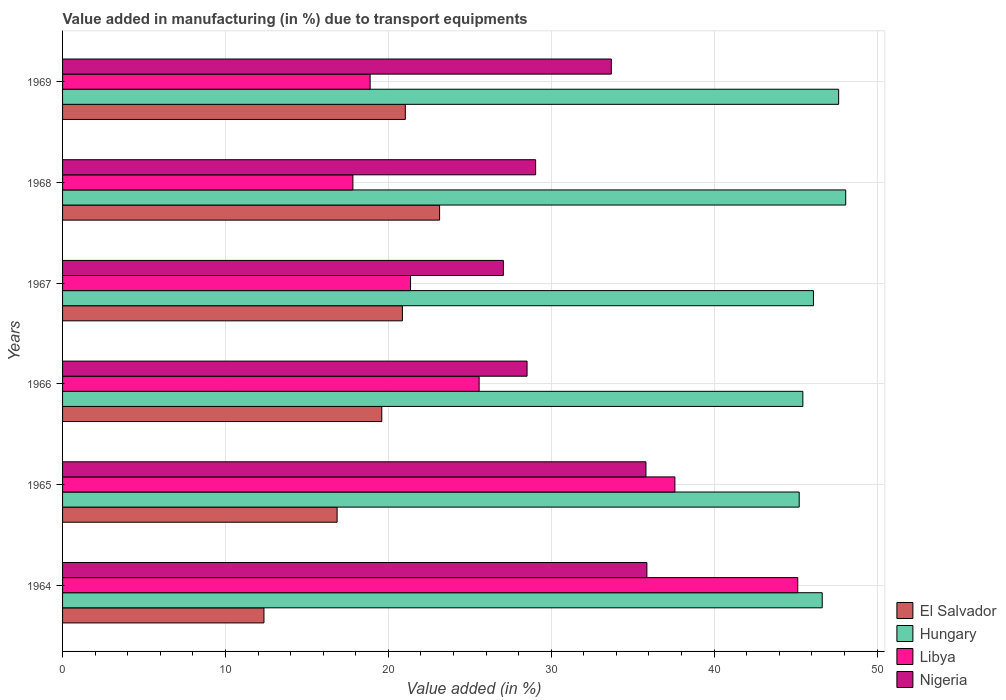How many different coloured bars are there?
Your response must be concise. 4. Are the number of bars per tick equal to the number of legend labels?
Offer a terse response. Yes. Are the number of bars on each tick of the Y-axis equal?
Offer a terse response. Yes. How many bars are there on the 5th tick from the top?
Make the answer very short. 4. What is the label of the 4th group of bars from the top?
Provide a succinct answer. 1966. What is the percentage of value added in manufacturing due to transport equipments in Nigeria in 1966?
Give a very brief answer. 28.52. Across all years, what is the maximum percentage of value added in manufacturing due to transport equipments in Nigeria?
Give a very brief answer. 35.87. Across all years, what is the minimum percentage of value added in manufacturing due to transport equipments in Libya?
Provide a short and direct response. 17.82. In which year was the percentage of value added in manufacturing due to transport equipments in El Salvador maximum?
Your response must be concise. 1968. In which year was the percentage of value added in manufacturing due to transport equipments in Hungary minimum?
Keep it short and to the point. 1965. What is the total percentage of value added in manufacturing due to transport equipments in Libya in the graph?
Offer a terse response. 166.37. What is the difference between the percentage of value added in manufacturing due to transport equipments in El Salvador in 1964 and that in 1969?
Keep it short and to the point. -8.68. What is the difference between the percentage of value added in manufacturing due to transport equipments in Libya in 1964 and the percentage of value added in manufacturing due to transport equipments in Nigeria in 1966?
Your answer should be very brief. 16.62. What is the average percentage of value added in manufacturing due to transport equipments in Libya per year?
Provide a succinct answer. 27.73. In the year 1966, what is the difference between the percentage of value added in manufacturing due to transport equipments in Hungary and percentage of value added in manufacturing due to transport equipments in Libya?
Provide a short and direct response. 19.87. What is the ratio of the percentage of value added in manufacturing due to transport equipments in Libya in 1968 to that in 1969?
Ensure brevity in your answer.  0.94. What is the difference between the highest and the second highest percentage of value added in manufacturing due to transport equipments in Hungary?
Provide a short and direct response. 0.43. What is the difference between the highest and the lowest percentage of value added in manufacturing due to transport equipments in Hungary?
Offer a terse response. 2.86. Is it the case that in every year, the sum of the percentage of value added in manufacturing due to transport equipments in El Salvador and percentage of value added in manufacturing due to transport equipments in Nigeria is greater than the sum of percentage of value added in manufacturing due to transport equipments in Libya and percentage of value added in manufacturing due to transport equipments in Hungary?
Make the answer very short. No. What does the 1st bar from the top in 1966 represents?
Your answer should be very brief. Nigeria. What does the 2nd bar from the bottom in 1964 represents?
Your answer should be very brief. Hungary. How many bars are there?
Offer a terse response. 24. What is the difference between two consecutive major ticks on the X-axis?
Provide a short and direct response. 10. Does the graph contain any zero values?
Provide a succinct answer. No. Does the graph contain grids?
Ensure brevity in your answer.  Yes. How are the legend labels stacked?
Offer a terse response. Vertical. What is the title of the graph?
Make the answer very short. Value added in manufacturing (in %) due to transport equipments. What is the label or title of the X-axis?
Offer a very short reply. Value added (in %). What is the Value added (in %) of El Salvador in 1964?
Ensure brevity in your answer.  12.36. What is the Value added (in %) in Hungary in 1964?
Ensure brevity in your answer.  46.64. What is the Value added (in %) of Libya in 1964?
Make the answer very short. 45.13. What is the Value added (in %) of Nigeria in 1964?
Your answer should be compact. 35.87. What is the Value added (in %) of El Salvador in 1965?
Offer a very short reply. 16.85. What is the Value added (in %) of Hungary in 1965?
Ensure brevity in your answer.  45.22. What is the Value added (in %) in Libya in 1965?
Give a very brief answer. 37.59. What is the Value added (in %) in Nigeria in 1965?
Give a very brief answer. 35.82. What is the Value added (in %) of El Salvador in 1966?
Give a very brief answer. 19.6. What is the Value added (in %) of Hungary in 1966?
Ensure brevity in your answer.  45.45. What is the Value added (in %) of Libya in 1966?
Give a very brief answer. 25.57. What is the Value added (in %) of Nigeria in 1966?
Offer a terse response. 28.52. What is the Value added (in %) in El Salvador in 1967?
Keep it short and to the point. 20.86. What is the Value added (in %) of Hungary in 1967?
Ensure brevity in your answer.  46.1. What is the Value added (in %) of Libya in 1967?
Give a very brief answer. 21.36. What is the Value added (in %) in Nigeria in 1967?
Provide a succinct answer. 27.06. What is the Value added (in %) in El Salvador in 1968?
Your answer should be compact. 23.15. What is the Value added (in %) in Hungary in 1968?
Make the answer very short. 48.08. What is the Value added (in %) of Libya in 1968?
Your answer should be very brief. 17.82. What is the Value added (in %) of Nigeria in 1968?
Offer a terse response. 29.04. What is the Value added (in %) of El Salvador in 1969?
Keep it short and to the point. 21.04. What is the Value added (in %) in Hungary in 1969?
Make the answer very short. 47.65. What is the Value added (in %) in Libya in 1969?
Offer a terse response. 18.88. What is the Value added (in %) of Nigeria in 1969?
Offer a terse response. 33.69. Across all years, what is the maximum Value added (in %) of El Salvador?
Provide a succinct answer. 23.15. Across all years, what is the maximum Value added (in %) in Hungary?
Your answer should be compact. 48.08. Across all years, what is the maximum Value added (in %) of Libya?
Offer a very short reply. 45.13. Across all years, what is the maximum Value added (in %) in Nigeria?
Provide a short and direct response. 35.87. Across all years, what is the minimum Value added (in %) of El Salvador?
Provide a short and direct response. 12.36. Across all years, what is the minimum Value added (in %) of Hungary?
Provide a short and direct response. 45.22. Across all years, what is the minimum Value added (in %) of Libya?
Offer a very short reply. 17.82. Across all years, what is the minimum Value added (in %) in Nigeria?
Ensure brevity in your answer.  27.06. What is the total Value added (in %) of El Salvador in the graph?
Make the answer very short. 113.87. What is the total Value added (in %) of Hungary in the graph?
Offer a very short reply. 279.13. What is the total Value added (in %) in Libya in the graph?
Your answer should be compact. 166.37. What is the total Value added (in %) in Nigeria in the graph?
Your answer should be very brief. 190. What is the difference between the Value added (in %) in El Salvador in 1964 and that in 1965?
Provide a short and direct response. -4.49. What is the difference between the Value added (in %) of Hungary in 1964 and that in 1965?
Your answer should be very brief. 1.41. What is the difference between the Value added (in %) of Libya in 1964 and that in 1965?
Offer a very short reply. 7.54. What is the difference between the Value added (in %) of Nigeria in 1964 and that in 1965?
Make the answer very short. 0.06. What is the difference between the Value added (in %) in El Salvador in 1964 and that in 1966?
Keep it short and to the point. -7.23. What is the difference between the Value added (in %) in Hungary in 1964 and that in 1966?
Provide a succinct answer. 1.19. What is the difference between the Value added (in %) of Libya in 1964 and that in 1966?
Your response must be concise. 19.56. What is the difference between the Value added (in %) of Nigeria in 1964 and that in 1966?
Ensure brevity in your answer.  7.36. What is the difference between the Value added (in %) in El Salvador in 1964 and that in 1967?
Offer a terse response. -8.5. What is the difference between the Value added (in %) in Hungary in 1964 and that in 1967?
Your answer should be compact. 0.54. What is the difference between the Value added (in %) in Libya in 1964 and that in 1967?
Offer a terse response. 23.77. What is the difference between the Value added (in %) of Nigeria in 1964 and that in 1967?
Provide a short and direct response. 8.81. What is the difference between the Value added (in %) in El Salvador in 1964 and that in 1968?
Ensure brevity in your answer.  -10.78. What is the difference between the Value added (in %) of Hungary in 1964 and that in 1968?
Offer a terse response. -1.44. What is the difference between the Value added (in %) in Libya in 1964 and that in 1968?
Provide a succinct answer. 27.31. What is the difference between the Value added (in %) of Nigeria in 1964 and that in 1968?
Make the answer very short. 6.83. What is the difference between the Value added (in %) of El Salvador in 1964 and that in 1969?
Your response must be concise. -8.68. What is the difference between the Value added (in %) of Hungary in 1964 and that in 1969?
Offer a very short reply. -1.01. What is the difference between the Value added (in %) in Libya in 1964 and that in 1969?
Your response must be concise. 26.25. What is the difference between the Value added (in %) of Nigeria in 1964 and that in 1969?
Your answer should be compact. 2.18. What is the difference between the Value added (in %) in El Salvador in 1965 and that in 1966?
Your response must be concise. -2.74. What is the difference between the Value added (in %) of Hungary in 1965 and that in 1966?
Give a very brief answer. -0.22. What is the difference between the Value added (in %) in Libya in 1965 and that in 1966?
Make the answer very short. 12.02. What is the difference between the Value added (in %) of Nigeria in 1965 and that in 1966?
Keep it short and to the point. 7.3. What is the difference between the Value added (in %) of El Salvador in 1965 and that in 1967?
Provide a short and direct response. -4.01. What is the difference between the Value added (in %) in Hungary in 1965 and that in 1967?
Ensure brevity in your answer.  -0.88. What is the difference between the Value added (in %) of Libya in 1965 and that in 1967?
Provide a succinct answer. 16.23. What is the difference between the Value added (in %) of Nigeria in 1965 and that in 1967?
Keep it short and to the point. 8.75. What is the difference between the Value added (in %) of El Salvador in 1965 and that in 1968?
Offer a terse response. -6.29. What is the difference between the Value added (in %) of Hungary in 1965 and that in 1968?
Keep it short and to the point. -2.86. What is the difference between the Value added (in %) of Libya in 1965 and that in 1968?
Your answer should be compact. 19.77. What is the difference between the Value added (in %) of Nigeria in 1965 and that in 1968?
Ensure brevity in your answer.  6.77. What is the difference between the Value added (in %) of El Salvador in 1965 and that in 1969?
Provide a succinct answer. -4.19. What is the difference between the Value added (in %) of Hungary in 1965 and that in 1969?
Provide a succinct answer. -2.42. What is the difference between the Value added (in %) of Libya in 1965 and that in 1969?
Offer a terse response. 18.71. What is the difference between the Value added (in %) in Nigeria in 1965 and that in 1969?
Ensure brevity in your answer.  2.13. What is the difference between the Value added (in %) in El Salvador in 1966 and that in 1967?
Provide a succinct answer. -1.27. What is the difference between the Value added (in %) of Hungary in 1966 and that in 1967?
Your answer should be very brief. -0.65. What is the difference between the Value added (in %) of Libya in 1966 and that in 1967?
Keep it short and to the point. 4.21. What is the difference between the Value added (in %) in Nigeria in 1966 and that in 1967?
Ensure brevity in your answer.  1.45. What is the difference between the Value added (in %) of El Salvador in 1966 and that in 1968?
Your response must be concise. -3.55. What is the difference between the Value added (in %) of Hungary in 1966 and that in 1968?
Offer a very short reply. -2.63. What is the difference between the Value added (in %) in Libya in 1966 and that in 1968?
Provide a short and direct response. 7.75. What is the difference between the Value added (in %) in Nigeria in 1966 and that in 1968?
Give a very brief answer. -0.53. What is the difference between the Value added (in %) in El Salvador in 1966 and that in 1969?
Offer a terse response. -1.44. What is the difference between the Value added (in %) of Hungary in 1966 and that in 1969?
Make the answer very short. -2.2. What is the difference between the Value added (in %) of Libya in 1966 and that in 1969?
Make the answer very short. 6.69. What is the difference between the Value added (in %) of Nigeria in 1966 and that in 1969?
Offer a terse response. -5.17. What is the difference between the Value added (in %) of El Salvador in 1967 and that in 1968?
Provide a short and direct response. -2.28. What is the difference between the Value added (in %) of Hungary in 1967 and that in 1968?
Offer a terse response. -1.98. What is the difference between the Value added (in %) in Libya in 1967 and that in 1968?
Your answer should be very brief. 3.54. What is the difference between the Value added (in %) of Nigeria in 1967 and that in 1968?
Your response must be concise. -1.98. What is the difference between the Value added (in %) of El Salvador in 1967 and that in 1969?
Ensure brevity in your answer.  -0.18. What is the difference between the Value added (in %) of Hungary in 1967 and that in 1969?
Give a very brief answer. -1.55. What is the difference between the Value added (in %) in Libya in 1967 and that in 1969?
Provide a short and direct response. 2.48. What is the difference between the Value added (in %) in Nigeria in 1967 and that in 1969?
Your response must be concise. -6.63. What is the difference between the Value added (in %) in El Salvador in 1968 and that in 1969?
Give a very brief answer. 2.1. What is the difference between the Value added (in %) in Hungary in 1968 and that in 1969?
Make the answer very short. 0.43. What is the difference between the Value added (in %) in Libya in 1968 and that in 1969?
Offer a very short reply. -1.06. What is the difference between the Value added (in %) in Nigeria in 1968 and that in 1969?
Provide a short and direct response. -4.65. What is the difference between the Value added (in %) of El Salvador in 1964 and the Value added (in %) of Hungary in 1965?
Give a very brief answer. -32.86. What is the difference between the Value added (in %) in El Salvador in 1964 and the Value added (in %) in Libya in 1965?
Offer a very short reply. -25.23. What is the difference between the Value added (in %) in El Salvador in 1964 and the Value added (in %) in Nigeria in 1965?
Ensure brevity in your answer.  -23.45. What is the difference between the Value added (in %) in Hungary in 1964 and the Value added (in %) in Libya in 1965?
Provide a succinct answer. 9.04. What is the difference between the Value added (in %) in Hungary in 1964 and the Value added (in %) in Nigeria in 1965?
Your answer should be very brief. 10.82. What is the difference between the Value added (in %) in Libya in 1964 and the Value added (in %) in Nigeria in 1965?
Keep it short and to the point. 9.32. What is the difference between the Value added (in %) in El Salvador in 1964 and the Value added (in %) in Hungary in 1966?
Offer a very short reply. -33.08. What is the difference between the Value added (in %) of El Salvador in 1964 and the Value added (in %) of Libya in 1966?
Your response must be concise. -13.21. What is the difference between the Value added (in %) of El Salvador in 1964 and the Value added (in %) of Nigeria in 1966?
Your response must be concise. -16.15. What is the difference between the Value added (in %) in Hungary in 1964 and the Value added (in %) in Libya in 1966?
Provide a succinct answer. 21.06. What is the difference between the Value added (in %) of Hungary in 1964 and the Value added (in %) of Nigeria in 1966?
Give a very brief answer. 18.12. What is the difference between the Value added (in %) of Libya in 1964 and the Value added (in %) of Nigeria in 1966?
Your answer should be very brief. 16.62. What is the difference between the Value added (in %) of El Salvador in 1964 and the Value added (in %) of Hungary in 1967?
Ensure brevity in your answer.  -33.73. What is the difference between the Value added (in %) of El Salvador in 1964 and the Value added (in %) of Libya in 1967?
Your answer should be compact. -9. What is the difference between the Value added (in %) in El Salvador in 1964 and the Value added (in %) in Nigeria in 1967?
Your response must be concise. -14.7. What is the difference between the Value added (in %) in Hungary in 1964 and the Value added (in %) in Libya in 1967?
Make the answer very short. 25.27. What is the difference between the Value added (in %) in Hungary in 1964 and the Value added (in %) in Nigeria in 1967?
Ensure brevity in your answer.  19.57. What is the difference between the Value added (in %) of Libya in 1964 and the Value added (in %) of Nigeria in 1967?
Provide a short and direct response. 18.07. What is the difference between the Value added (in %) of El Salvador in 1964 and the Value added (in %) of Hungary in 1968?
Offer a very short reply. -35.72. What is the difference between the Value added (in %) in El Salvador in 1964 and the Value added (in %) in Libya in 1968?
Your answer should be compact. -5.46. What is the difference between the Value added (in %) in El Salvador in 1964 and the Value added (in %) in Nigeria in 1968?
Keep it short and to the point. -16.68. What is the difference between the Value added (in %) of Hungary in 1964 and the Value added (in %) of Libya in 1968?
Your answer should be very brief. 28.81. What is the difference between the Value added (in %) in Hungary in 1964 and the Value added (in %) in Nigeria in 1968?
Your response must be concise. 17.59. What is the difference between the Value added (in %) of Libya in 1964 and the Value added (in %) of Nigeria in 1968?
Your answer should be compact. 16.09. What is the difference between the Value added (in %) in El Salvador in 1964 and the Value added (in %) in Hungary in 1969?
Your response must be concise. -35.28. What is the difference between the Value added (in %) in El Salvador in 1964 and the Value added (in %) in Libya in 1969?
Your response must be concise. -6.52. What is the difference between the Value added (in %) in El Salvador in 1964 and the Value added (in %) in Nigeria in 1969?
Offer a terse response. -21.33. What is the difference between the Value added (in %) of Hungary in 1964 and the Value added (in %) of Libya in 1969?
Give a very brief answer. 27.75. What is the difference between the Value added (in %) of Hungary in 1964 and the Value added (in %) of Nigeria in 1969?
Ensure brevity in your answer.  12.95. What is the difference between the Value added (in %) in Libya in 1964 and the Value added (in %) in Nigeria in 1969?
Your answer should be very brief. 11.44. What is the difference between the Value added (in %) of El Salvador in 1965 and the Value added (in %) of Hungary in 1966?
Provide a succinct answer. -28.59. What is the difference between the Value added (in %) in El Salvador in 1965 and the Value added (in %) in Libya in 1966?
Give a very brief answer. -8.72. What is the difference between the Value added (in %) in El Salvador in 1965 and the Value added (in %) in Nigeria in 1966?
Make the answer very short. -11.66. What is the difference between the Value added (in %) of Hungary in 1965 and the Value added (in %) of Libya in 1966?
Offer a terse response. 19.65. What is the difference between the Value added (in %) in Hungary in 1965 and the Value added (in %) in Nigeria in 1966?
Offer a terse response. 16.71. What is the difference between the Value added (in %) of Libya in 1965 and the Value added (in %) of Nigeria in 1966?
Your response must be concise. 9.08. What is the difference between the Value added (in %) of El Salvador in 1965 and the Value added (in %) of Hungary in 1967?
Offer a terse response. -29.24. What is the difference between the Value added (in %) in El Salvador in 1965 and the Value added (in %) in Libya in 1967?
Make the answer very short. -4.51. What is the difference between the Value added (in %) of El Salvador in 1965 and the Value added (in %) of Nigeria in 1967?
Keep it short and to the point. -10.21. What is the difference between the Value added (in %) of Hungary in 1965 and the Value added (in %) of Libya in 1967?
Give a very brief answer. 23.86. What is the difference between the Value added (in %) of Hungary in 1965 and the Value added (in %) of Nigeria in 1967?
Your response must be concise. 18.16. What is the difference between the Value added (in %) in Libya in 1965 and the Value added (in %) in Nigeria in 1967?
Offer a very short reply. 10.53. What is the difference between the Value added (in %) of El Salvador in 1965 and the Value added (in %) of Hungary in 1968?
Your response must be concise. -31.22. What is the difference between the Value added (in %) in El Salvador in 1965 and the Value added (in %) in Libya in 1968?
Your answer should be very brief. -0.97. What is the difference between the Value added (in %) of El Salvador in 1965 and the Value added (in %) of Nigeria in 1968?
Make the answer very short. -12.19. What is the difference between the Value added (in %) of Hungary in 1965 and the Value added (in %) of Libya in 1968?
Make the answer very short. 27.4. What is the difference between the Value added (in %) of Hungary in 1965 and the Value added (in %) of Nigeria in 1968?
Give a very brief answer. 16.18. What is the difference between the Value added (in %) in Libya in 1965 and the Value added (in %) in Nigeria in 1968?
Your answer should be very brief. 8.55. What is the difference between the Value added (in %) in El Salvador in 1965 and the Value added (in %) in Hungary in 1969?
Your response must be concise. -30.79. What is the difference between the Value added (in %) in El Salvador in 1965 and the Value added (in %) in Libya in 1969?
Your answer should be very brief. -2.03. What is the difference between the Value added (in %) in El Salvador in 1965 and the Value added (in %) in Nigeria in 1969?
Offer a terse response. -16.84. What is the difference between the Value added (in %) of Hungary in 1965 and the Value added (in %) of Libya in 1969?
Make the answer very short. 26.34. What is the difference between the Value added (in %) of Hungary in 1965 and the Value added (in %) of Nigeria in 1969?
Keep it short and to the point. 11.53. What is the difference between the Value added (in %) of Libya in 1965 and the Value added (in %) of Nigeria in 1969?
Give a very brief answer. 3.9. What is the difference between the Value added (in %) in El Salvador in 1966 and the Value added (in %) in Hungary in 1967?
Your answer should be compact. -26.5. What is the difference between the Value added (in %) of El Salvador in 1966 and the Value added (in %) of Libya in 1967?
Provide a succinct answer. -1.77. What is the difference between the Value added (in %) of El Salvador in 1966 and the Value added (in %) of Nigeria in 1967?
Your response must be concise. -7.46. What is the difference between the Value added (in %) in Hungary in 1966 and the Value added (in %) in Libya in 1967?
Provide a short and direct response. 24.08. What is the difference between the Value added (in %) in Hungary in 1966 and the Value added (in %) in Nigeria in 1967?
Offer a terse response. 18.38. What is the difference between the Value added (in %) in Libya in 1966 and the Value added (in %) in Nigeria in 1967?
Keep it short and to the point. -1.49. What is the difference between the Value added (in %) of El Salvador in 1966 and the Value added (in %) of Hungary in 1968?
Offer a very short reply. -28.48. What is the difference between the Value added (in %) in El Salvador in 1966 and the Value added (in %) in Libya in 1968?
Give a very brief answer. 1.77. What is the difference between the Value added (in %) in El Salvador in 1966 and the Value added (in %) in Nigeria in 1968?
Your answer should be compact. -9.45. What is the difference between the Value added (in %) in Hungary in 1966 and the Value added (in %) in Libya in 1968?
Your answer should be very brief. 27.62. What is the difference between the Value added (in %) in Hungary in 1966 and the Value added (in %) in Nigeria in 1968?
Keep it short and to the point. 16.4. What is the difference between the Value added (in %) of Libya in 1966 and the Value added (in %) of Nigeria in 1968?
Offer a terse response. -3.47. What is the difference between the Value added (in %) of El Salvador in 1966 and the Value added (in %) of Hungary in 1969?
Keep it short and to the point. -28.05. What is the difference between the Value added (in %) of El Salvador in 1966 and the Value added (in %) of Libya in 1969?
Provide a succinct answer. 0.72. What is the difference between the Value added (in %) in El Salvador in 1966 and the Value added (in %) in Nigeria in 1969?
Provide a short and direct response. -14.09. What is the difference between the Value added (in %) in Hungary in 1966 and the Value added (in %) in Libya in 1969?
Provide a short and direct response. 26.56. What is the difference between the Value added (in %) in Hungary in 1966 and the Value added (in %) in Nigeria in 1969?
Keep it short and to the point. 11.76. What is the difference between the Value added (in %) in Libya in 1966 and the Value added (in %) in Nigeria in 1969?
Keep it short and to the point. -8.12. What is the difference between the Value added (in %) in El Salvador in 1967 and the Value added (in %) in Hungary in 1968?
Offer a terse response. -27.21. What is the difference between the Value added (in %) of El Salvador in 1967 and the Value added (in %) of Libya in 1968?
Your response must be concise. 3.04. What is the difference between the Value added (in %) of El Salvador in 1967 and the Value added (in %) of Nigeria in 1968?
Offer a terse response. -8.18. What is the difference between the Value added (in %) in Hungary in 1967 and the Value added (in %) in Libya in 1968?
Keep it short and to the point. 28.27. What is the difference between the Value added (in %) of Hungary in 1967 and the Value added (in %) of Nigeria in 1968?
Offer a very short reply. 17.06. What is the difference between the Value added (in %) in Libya in 1967 and the Value added (in %) in Nigeria in 1968?
Give a very brief answer. -7.68. What is the difference between the Value added (in %) in El Salvador in 1967 and the Value added (in %) in Hungary in 1969?
Offer a terse response. -26.78. What is the difference between the Value added (in %) of El Salvador in 1967 and the Value added (in %) of Libya in 1969?
Your answer should be compact. 1.98. What is the difference between the Value added (in %) in El Salvador in 1967 and the Value added (in %) in Nigeria in 1969?
Keep it short and to the point. -12.83. What is the difference between the Value added (in %) of Hungary in 1967 and the Value added (in %) of Libya in 1969?
Provide a succinct answer. 27.22. What is the difference between the Value added (in %) of Hungary in 1967 and the Value added (in %) of Nigeria in 1969?
Offer a very short reply. 12.41. What is the difference between the Value added (in %) in Libya in 1967 and the Value added (in %) in Nigeria in 1969?
Ensure brevity in your answer.  -12.33. What is the difference between the Value added (in %) in El Salvador in 1968 and the Value added (in %) in Hungary in 1969?
Provide a succinct answer. -24.5. What is the difference between the Value added (in %) of El Salvador in 1968 and the Value added (in %) of Libya in 1969?
Provide a short and direct response. 4.26. What is the difference between the Value added (in %) of El Salvador in 1968 and the Value added (in %) of Nigeria in 1969?
Keep it short and to the point. -10.54. What is the difference between the Value added (in %) in Hungary in 1968 and the Value added (in %) in Libya in 1969?
Give a very brief answer. 29.2. What is the difference between the Value added (in %) in Hungary in 1968 and the Value added (in %) in Nigeria in 1969?
Offer a terse response. 14.39. What is the difference between the Value added (in %) in Libya in 1968 and the Value added (in %) in Nigeria in 1969?
Your response must be concise. -15.87. What is the average Value added (in %) in El Salvador per year?
Your response must be concise. 18.98. What is the average Value added (in %) of Hungary per year?
Offer a very short reply. 46.52. What is the average Value added (in %) of Libya per year?
Offer a terse response. 27.73. What is the average Value added (in %) of Nigeria per year?
Offer a very short reply. 31.67. In the year 1964, what is the difference between the Value added (in %) of El Salvador and Value added (in %) of Hungary?
Offer a terse response. -34.27. In the year 1964, what is the difference between the Value added (in %) in El Salvador and Value added (in %) in Libya?
Provide a succinct answer. -32.77. In the year 1964, what is the difference between the Value added (in %) of El Salvador and Value added (in %) of Nigeria?
Your response must be concise. -23.51. In the year 1964, what is the difference between the Value added (in %) of Hungary and Value added (in %) of Libya?
Offer a very short reply. 1.5. In the year 1964, what is the difference between the Value added (in %) in Hungary and Value added (in %) in Nigeria?
Your response must be concise. 10.76. In the year 1964, what is the difference between the Value added (in %) in Libya and Value added (in %) in Nigeria?
Give a very brief answer. 9.26. In the year 1965, what is the difference between the Value added (in %) in El Salvador and Value added (in %) in Hungary?
Ensure brevity in your answer.  -28.37. In the year 1965, what is the difference between the Value added (in %) of El Salvador and Value added (in %) of Libya?
Offer a very short reply. -20.74. In the year 1965, what is the difference between the Value added (in %) in El Salvador and Value added (in %) in Nigeria?
Your response must be concise. -18.96. In the year 1965, what is the difference between the Value added (in %) in Hungary and Value added (in %) in Libya?
Provide a short and direct response. 7.63. In the year 1965, what is the difference between the Value added (in %) of Hungary and Value added (in %) of Nigeria?
Ensure brevity in your answer.  9.41. In the year 1965, what is the difference between the Value added (in %) in Libya and Value added (in %) in Nigeria?
Give a very brief answer. 1.78. In the year 1966, what is the difference between the Value added (in %) of El Salvador and Value added (in %) of Hungary?
Your response must be concise. -25.85. In the year 1966, what is the difference between the Value added (in %) of El Salvador and Value added (in %) of Libya?
Give a very brief answer. -5.98. In the year 1966, what is the difference between the Value added (in %) of El Salvador and Value added (in %) of Nigeria?
Keep it short and to the point. -8.92. In the year 1966, what is the difference between the Value added (in %) in Hungary and Value added (in %) in Libya?
Keep it short and to the point. 19.87. In the year 1966, what is the difference between the Value added (in %) in Hungary and Value added (in %) in Nigeria?
Your answer should be very brief. 16.93. In the year 1966, what is the difference between the Value added (in %) of Libya and Value added (in %) of Nigeria?
Your response must be concise. -2.94. In the year 1967, what is the difference between the Value added (in %) in El Salvador and Value added (in %) in Hungary?
Give a very brief answer. -25.23. In the year 1967, what is the difference between the Value added (in %) of El Salvador and Value added (in %) of Libya?
Provide a succinct answer. -0.5. In the year 1967, what is the difference between the Value added (in %) of El Salvador and Value added (in %) of Nigeria?
Give a very brief answer. -6.2. In the year 1967, what is the difference between the Value added (in %) in Hungary and Value added (in %) in Libya?
Keep it short and to the point. 24.73. In the year 1967, what is the difference between the Value added (in %) in Hungary and Value added (in %) in Nigeria?
Make the answer very short. 19.04. In the year 1967, what is the difference between the Value added (in %) of Libya and Value added (in %) of Nigeria?
Keep it short and to the point. -5.7. In the year 1968, what is the difference between the Value added (in %) of El Salvador and Value added (in %) of Hungary?
Make the answer very short. -24.93. In the year 1968, what is the difference between the Value added (in %) in El Salvador and Value added (in %) in Libya?
Keep it short and to the point. 5.32. In the year 1968, what is the difference between the Value added (in %) in El Salvador and Value added (in %) in Nigeria?
Your response must be concise. -5.9. In the year 1968, what is the difference between the Value added (in %) in Hungary and Value added (in %) in Libya?
Make the answer very short. 30.26. In the year 1968, what is the difference between the Value added (in %) in Hungary and Value added (in %) in Nigeria?
Give a very brief answer. 19.04. In the year 1968, what is the difference between the Value added (in %) in Libya and Value added (in %) in Nigeria?
Your answer should be compact. -11.22. In the year 1969, what is the difference between the Value added (in %) in El Salvador and Value added (in %) in Hungary?
Offer a very short reply. -26.6. In the year 1969, what is the difference between the Value added (in %) of El Salvador and Value added (in %) of Libya?
Keep it short and to the point. 2.16. In the year 1969, what is the difference between the Value added (in %) of El Salvador and Value added (in %) of Nigeria?
Your answer should be compact. -12.65. In the year 1969, what is the difference between the Value added (in %) in Hungary and Value added (in %) in Libya?
Offer a terse response. 28.76. In the year 1969, what is the difference between the Value added (in %) of Hungary and Value added (in %) of Nigeria?
Provide a short and direct response. 13.96. In the year 1969, what is the difference between the Value added (in %) of Libya and Value added (in %) of Nigeria?
Ensure brevity in your answer.  -14.81. What is the ratio of the Value added (in %) in El Salvador in 1964 to that in 1965?
Provide a succinct answer. 0.73. What is the ratio of the Value added (in %) in Hungary in 1964 to that in 1965?
Your response must be concise. 1.03. What is the ratio of the Value added (in %) in Libya in 1964 to that in 1965?
Make the answer very short. 1.2. What is the ratio of the Value added (in %) in Nigeria in 1964 to that in 1965?
Offer a terse response. 1. What is the ratio of the Value added (in %) in El Salvador in 1964 to that in 1966?
Ensure brevity in your answer.  0.63. What is the ratio of the Value added (in %) in Hungary in 1964 to that in 1966?
Your answer should be compact. 1.03. What is the ratio of the Value added (in %) in Libya in 1964 to that in 1966?
Offer a terse response. 1.76. What is the ratio of the Value added (in %) of Nigeria in 1964 to that in 1966?
Ensure brevity in your answer.  1.26. What is the ratio of the Value added (in %) of El Salvador in 1964 to that in 1967?
Your response must be concise. 0.59. What is the ratio of the Value added (in %) of Hungary in 1964 to that in 1967?
Your answer should be compact. 1.01. What is the ratio of the Value added (in %) of Libya in 1964 to that in 1967?
Offer a very short reply. 2.11. What is the ratio of the Value added (in %) in Nigeria in 1964 to that in 1967?
Provide a short and direct response. 1.33. What is the ratio of the Value added (in %) of El Salvador in 1964 to that in 1968?
Give a very brief answer. 0.53. What is the ratio of the Value added (in %) of Libya in 1964 to that in 1968?
Your response must be concise. 2.53. What is the ratio of the Value added (in %) of Nigeria in 1964 to that in 1968?
Offer a very short reply. 1.24. What is the ratio of the Value added (in %) in El Salvador in 1964 to that in 1969?
Your answer should be very brief. 0.59. What is the ratio of the Value added (in %) in Hungary in 1964 to that in 1969?
Your response must be concise. 0.98. What is the ratio of the Value added (in %) of Libya in 1964 to that in 1969?
Provide a short and direct response. 2.39. What is the ratio of the Value added (in %) of Nigeria in 1964 to that in 1969?
Offer a terse response. 1.06. What is the ratio of the Value added (in %) in El Salvador in 1965 to that in 1966?
Your answer should be compact. 0.86. What is the ratio of the Value added (in %) of Libya in 1965 to that in 1966?
Ensure brevity in your answer.  1.47. What is the ratio of the Value added (in %) in Nigeria in 1965 to that in 1966?
Give a very brief answer. 1.26. What is the ratio of the Value added (in %) of El Salvador in 1965 to that in 1967?
Provide a short and direct response. 0.81. What is the ratio of the Value added (in %) of Hungary in 1965 to that in 1967?
Make the answer very short. 0.98. What is the ratio of the Value added (in %) of Libya in 1965 to that in 1967?
Offer a very short reply. 1.76. What is the ratio of the Value added (in %) of Nigeria in 1965 to that in 1967?
Ensure brevity in your answer.  1.32. What is the ratio of the Value added (in %) in El Salvador in 1965 to that in 1968?
Offer a very short reply. 0.73. What is the ratio of the Value added (in %) of Hungary in 1965 to that in 1968?
Provide a succinct answer. 0.94. What is the ratio of the Value added (in %) in Libya in 1965 to that in 1968?
Provide a short and direct response. 2.11. What is the ratio of the Value added (in %) of Nigeria in 1965 to that in 1968?
Provide a succinct answer. 1.23. What is the ratio of the Value added (in %) of El Salvador in 1965 to that in 1969?
Give a very brief answer. 0.8. What is the ratio of the Value added (in %) in Hungary in 1965 to that in 1969?
Provide a short and direct response. 0.95. What is the ratio of the Value added (in %) of Libya in 1965 to that in 1969?
Your answer should be very brief. 1.99. What is the ratio of the Value added (in %) in Nigeria in 1965 to that in 1969?
Provide a succinct answer. 1.06. What is the ratio of the Value added (in %) in El Salvador in 1966 to that in 1967?
Provide a succinct answer. 0.94. What is the ratio of the Value added (in %) in Hungary in 1966 to that in 1967?
Your answer should be compact. 0.99. What is the ratio of the Value added (in %) of Libya in 1966 to that in 1967?
Give a very brief answer. 1.2. What is the ratio of the Value added (in %) in Nigeria in 1966 to that in 1967?
Your response must be concise. 1.05. What is the ratio of the Value added (in %) in El Salvador in 1966 to that in 1968?
Provide a succinct answer. 0.85. What is the ratio of the Value added (in %) of Hungary in 1966 to that in 1968?
Make the answer very short. 0.95. What is the ratio of the Value added (in %) in Libya in 1966 to that in 1968?
Your answer should be very brief. 1.43. What is the ratio of the Value added (in %) in Nigeria in 1966 to that in 1968?
Provide a succinct answer. 0.98. What is the ratio of the Value added (in %) of El Salvador in 1966 to that in 1969?
Provide a short and direct response. 0.93. What is the ratio of the Value added (in %) in Hungary in 1966 to that in 1969?
Give a very brief answer. 0.95. What is the ratio of the Value added (in %) of Libya in 1966 to that in 1969?
Your answer should be compact. 1.35. What is the ratio of the Value added (in %) of Nigeria in 1966 to that in 1969?
Keep it short and to the point. 0.85. What is the ratio of the Value added (in %) of El Salvador in 1967 to that in 1968?
Your answer should be very brief. 0.9. What is the ratio of the Value added (in %) of Hungary in 1967 to that in 1968?
Your response must be concise. 0.96. What is the ratio of the Value added (in %) of Libya in 1967 to that in 1968?
Your response must be concise. 1.2. What is the ratio of the Value added (in %) in Nigeria in 1967 to that in 1968?
Ensure brevity in your answer.  0.93. What is the ratio of the Value added (in %) in Hungary in 1967 to that in 1969?
Your response must be concise. 0.97. What is the ratio of the Value added (in %) in Libya in 1967 to that in 1969?
Provide a short and direct response. 1.13. What is the ratio of the Value added (in %) of Nigeria in 1967 to that in 1969?
Your answer should be compact. 0.8. What is the ratio of the Value added (in %) in El Salvador in 1968 to that in 1969?
Keep it short and to the point. 1.1. What is the ratio of the Value added (in %) of Hungary in 1968 to that in 1969?
Provide a short and direct response. 1.01. What is the ratio of the Value added (in %) in Libya in 1968 to that in 1969?
Your response must be concise. 0.94. What is the ratio of the Value added (in %) of Nigeria in 1968 to that in 1969?
Your response must be concise. 0.86. What is the difference between the highest and the second highest Value added (in %) of El Salvador?
Make the answer very short. 2.1. What is the difference between the highest and the second highest Value added (in %) in Hungary?
Keep it short and to the point. 0.43. What is the difference between the highest and the second highest Value added (in %) in Libya?
Ensure brevity in your answer.  7.54. What is the difference between the highest and the second highest Value added (in %) in Nigeria?
Ensure brevity in your answer.  0.06. What is the difference between the highest and the lowest Value added (in %) in El Salvador?
Give a very brief answer. 10.78. What is the difference between the highest and the lowest Value added (in %) in Hungary?
Your answer should be very brief. 2.86. What is the difference between the highest and the lowest Value added (in %) in Libya?
Ensure brevity in your answer.  27.31. What is the difference between the highest and the lowest Value added (in %) in Nigeria?
Offer a very short reply. 8.81. 